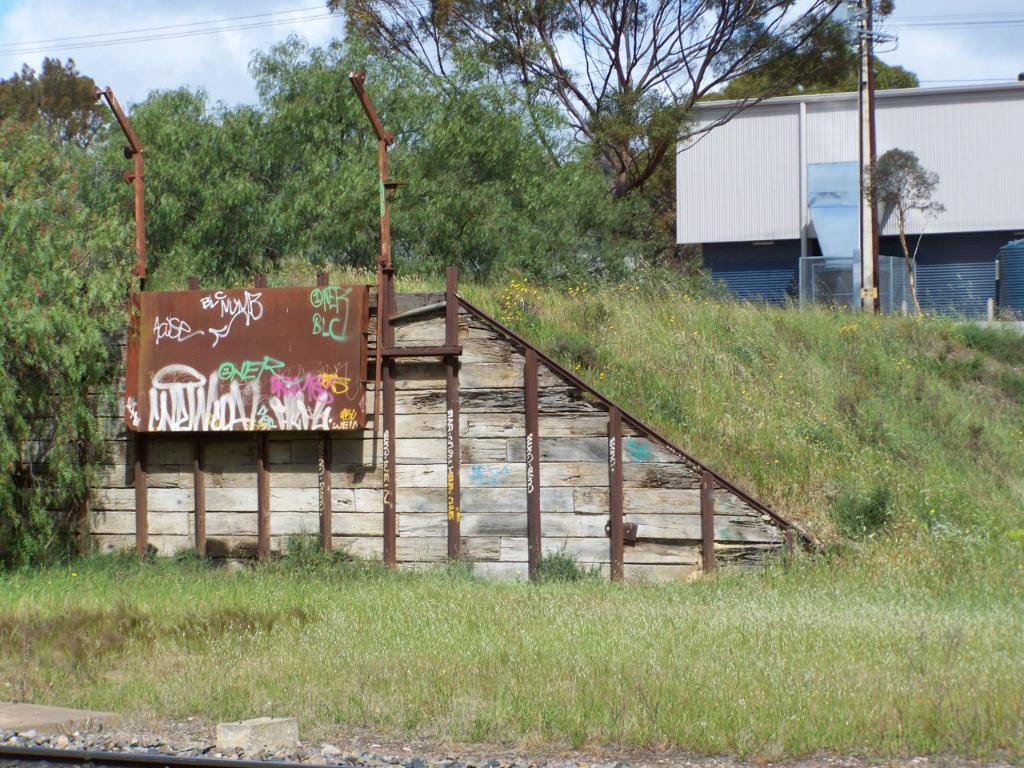In one or two sentences, can you explain what this image depicts? In this image we can see she's, electric poles, electric lights, electric cables, grass, trees and sky with clouds. 